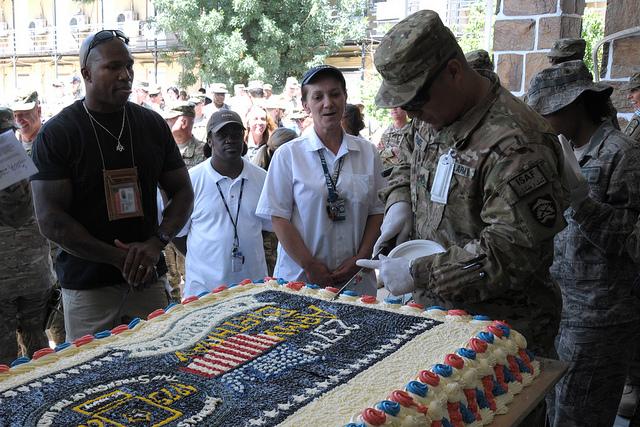Is the cake-cutter wearing gloves?
Write a very short answer. Yes. What rank and branch does the patch on the left arm of his fatigues denote?
Write a very short answer. Army. What does this cake represent?
Write a very short answer. Army. 